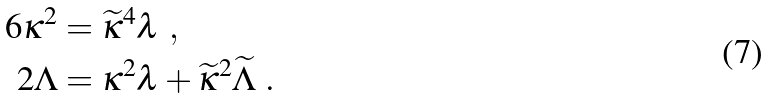<formula> <loc_0><loc_0><loc_500><loc_500>6 \kappa ^ { 2 } & = \widetilde { \kappa } ^ { 4 } \lambda \ , \\ 2 \Lambda & = \kappa ^ { 2 } \lambda + \widetilde { \kappa } ^ { 2 } \widetilde { \Lambda } \ .</formula> 